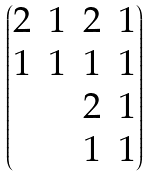<formula> <loc_0><loc_0><loc_500><loc_500>\begin{pmatrix} 2 & 1 & 2 & 1 \\ 1 & 1 & 1 & 1 \\ & & 2 & 1 \\ & & 1 & 1 \end{pmatrix}</formula> 